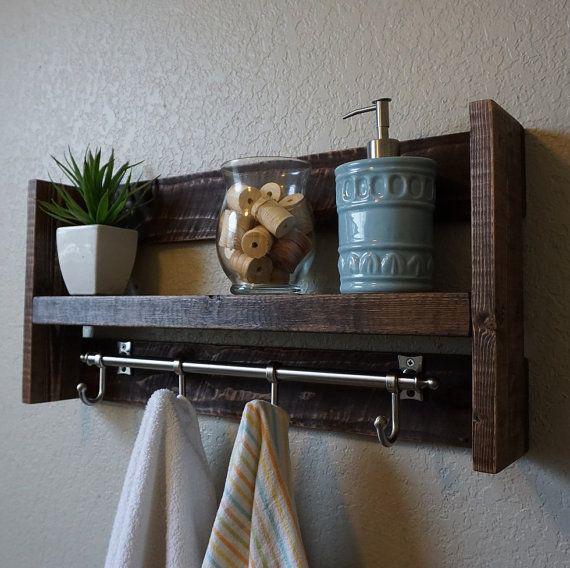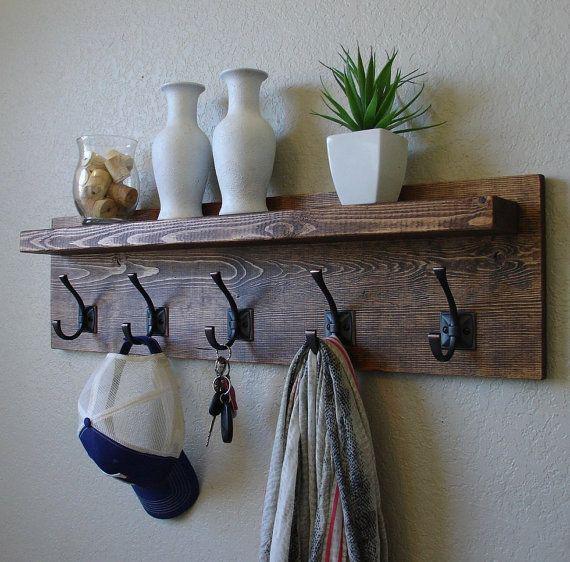The first image is the image on the left, the second image is the image on the right. Evaluate the accuracy of this statement regarding the images: "An image shows towels draped on hooks beneath a shelf containing a plant, jar of spools, and blue pump dispenser.". Is it true? Answer yes or no. Yes. The first image is the image on the left, the second image is the image on the right. Evaluate the accuracy of this statement regarding the images: "All wooden bathroom shelves are stained dark and open on both ends, with no side enclosure boards.". Is it true? Answer yes or no. No. 